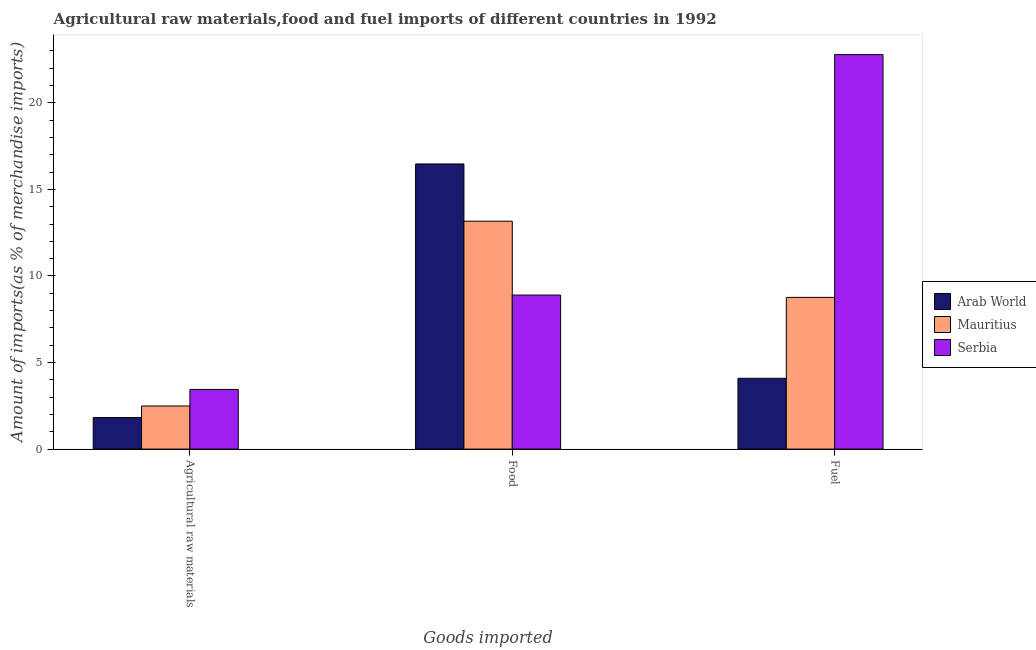How many different coloured bars are there?
Your response must be concise. 3. How many bars are there on the 1st tick from the left?
Provide a succinct answer. 3. How many bars are there on the 2nd tick from the right?
Provide a short and direct response. 3. What is the label of the 1st group of bars from the left?
Your answer should be very brief. Agricultural raw materials. What is the percentage of food imports in Serbia?
Your response must be concise. 8.9. Across all countries, what is the maximum percentage of fuel imports?
Ensure brevity in your answer.  22.79. Across all countries, what is the minimum percentage of raw materials imports?
Keep it short and to the point. 1.82. In which country was the percentage of food imports maximum?
Provide a short and direct response. Arab World. In which country was the percentage of fuel imports minimum?
Keep it short and to the point. Arab World. What is the total percentage of food imports in the graph?
Offer a very short reply. 38.53. What is the difference between the percentage of food imports in Mauritius and that in Arab World?
Provide a short and direct response. -3.31. What is the difference between the percentage of food imports in Mauritius and the percentage of raw materials imports in Serbia?
Provide a succinct answer. 9.72. What is the average percentage of raw materials imports per country?
Ensure brevity in your answer.  2.58. What is the difference between the percentage of raw materials imports and percentage of fuel imports in Arab World?
Your answer should be compact. -2.27. In how many countries, is the percentage of raw materials imports greater than 18 %?
Make the answer very short. 0. What is the ratio of the percentage of fuel imports in Mauritius to that in Arab World?
Your response must be concise. 2.14. Is the percentage of raw materials imports in Serbia less than that in Arab World?
Offer a terse response. No. Is the difference between the percentage of fuel imports in Mauritius and Arab World greater than the difference between the percentage of food imports in Mauritius and Arab World?
Offer a very short reply. Yes. What is the difference between the highest and the second highest percentage of fuel imports?
Provide a short and direct response. 14.02. What is the difference between the highest and the lowest percentage of raw materials imports?
Make the answer very short. 1.62. What does the 3rd bar from the left in Fuel represents?
Give a very brief answer. Serbia. What does the 1st bar from the right in Agricultural raw materials represents?
Keep it short and to the point. Serbia. What is the difference between two consecutive major ticks on the Y-axis?
Your answer should be compact. 5. Where does the legend appear in the graph?
Make the answer very short. Center right. How are the legend labels stacked?
Ensure brevity in your answer.  Vertical. What is the title of the graph?
Offer a very short reply. Agricultural raw materials,food and fuel imports of different countries in 1992. Does "Israel" appear as one of the legend labels in the graph?
Your response must be concise. No. What is the label or title of the X-axis?
Make the answer very short. Goods imported. What is the label or title of the Y-axis?
Ensure brevity in your answer.  Amount of imports(as % of merchandise imports). What is the Amount of imports(as % of merchandise imports) of Arab World in Agricultural raw materials?
Your answer should be compact. 1.82. What is the Amount of imports(as % of merchandise imports) in Mauritius in Agricultural raw materials?
Your response must be concise. 2.49. What is the Amount of imports(as % of merchandise imports) in Serbia in Agricultural raw materials?
Make the answer very short. 3.44. What is the Amount of imports(as % of merchandise imports) of Arab World in Food?
Your answer should be compact. 16.47. What is the Amount of imports(as % of merchandise imports) in Mauritius in Food?
Offer a terse response. 13.16. What is the Amount of imports(as % of merchandise imports) in Serbia in Food?
Provide a short and direct response. 8.9. What is the Amount of imports(as % of merchandise imports) in Arab World in Fuel?
Give a very brief answer. 4.09. What is the Amount of imports(as % of merchandise imports) of Mauritius in Fuel?
Keep it short and to the point. 8.76. What is the Amount of imports(as % of merchandise imports) in Serbia in Fuel?
Make the answer very short. 22.79. Across all Goods imported, what is the maximum Amount of imports(as % of merchandise imports) of Arab World?
Offer a very short reply. 16.47. Across all Goods imported, what is the maximum Amount of imports(as % of merchandise imports) in Mauritius?
Provide a short and direct response. 13.16. Across all Goods imported, what is the maximum Amount of imports(as % of merchandise imports) in Serbia?
Your answer should be very brief. 22.79. Across all Goods imported, what is the minimum Amount of imports(as % of merchandise imports) in Arab World?
Provide a succinct answer. 1.82. Across all Goods imported, what is the minimum Amount of imports(as % of merchandise imports) of Mauritius?
Make the answer very short. 2.49. Across all Goods imported, what is the minimum Amount of imports(as % of merchandise imports) in Serbia?
Your response must be concise. 3.44. What is the total Amount of imports(as % of merchandise imports) of Arab World in the graph?
Your answer should be very brief. 22.38. What is the total Amount of imports(as % of merchandise imports) of Mauritius in the graph?
Offer a terse response. 24.41. What is the total Amount of imports(as % of merchandise imports) of Serbia in the graph?
Offer a very short reply. 35.13. What is the difference between the Amount of imports(as % of merchandise imports) in Arab World in Agricultural raw materials and that in Food?
Offer a very short reply. -14.65. What is the difference between the Amount of imports(as % of merchandise imports) in Mauritius in Agricultural raw materials and that in Food?
Provide a succinct answer. -10.68. What is the difference between the Amount of imports(as % of merchandise imports) in Serbia in Agricultural raw materials and that in Food?
Your answer should be very brief. -5.45. What is the difference between the Amount of imports(as % of merchandise imports) of Arab World in Agricultural raw materials and that in Fuel?
Ensure brevity in your answer.  -2.27. What is the difference between the Amount of imports(as % of merchandise imports) in Mauritius in Agricultural raw materials and that in Fuel?
Your answer should be very brief. -6.27. What is the difference between the Amount of imports(as % of merchandise imports) of Serbia in Agricultural raw materials and that in Fuel?
Offer a very short reply. -19.34. What is the difference between the Amount of imports(as % of merchandise imports) of Arab World in Food and that in Fuel?
Make the answer very short. 12.38. What is the difference between the Amount of imports(as % of merchandise imports) of Mauritius in Food and that in Fuel?
Provide a short and direct response. 4.4. What is the difference between the Amount of imports(as % of merchandise imports) in Serbia in Food and that in Fuel?
Keep it short and to the point. -13.89. What is the difference between the Amount of imports(as % of merchandise imports) in Arab World in Agricultural raw materials and the Amount of imports(as % of merchandise imports) in Mauritius in Food?
Keep it short and to the point. -11.34. What is the difference between the Amount of imports(as % of merchandise imports) in Arab World in Agricultural raw materials and the Amount of imports(as % of merchandise imports) in Serbia in Food?
Offer a terse response. -7.08. What is the difference between the Amount of imports(as % of merchandise imports) in Mauritius in Agricultural raw materials and the Amount of imports(as % of merchandise imports) in Serbia in Food?
Make the answer very short. -6.41. What is the difference between the Amount of imports(as % of merchandise imports) of Arab World in Agricultural raw materials and the Amount of imports(as % of merchandise imports) of Mauritius in Fuel?
Offer a very short reply. -6.94. What is the difference between the Amount of imports(as % of merchandise imports) of Arab World in Agricultural raw materials and the Amount of imports(as % of merchandise imports) of Serbia in Fuel?
Your response must be concise. -20.97. What is the difference between the Amount of imports(as % of merchandise imports) in Mauritius in Agricultural raw materials and the Amount of imports(as % of merchandise imports) in Serbia in Fuel?
Provide a succinct answer. -20.3. What is the difference between the Amount of imports(as % of merchandise imports) in Arab World in Food and the Amount of imports(as % of merchandise imports) in Mauritius in Fuel?
Provide a short and direct response. 7.71. What is the difference between the Amount of imports(as % of merchandise imports) in Arab World in Food and the Amount of imports(as % of merchandise imports) in Serbia in Fuel?
Your answer should be compact. -6.32. What is the difference between the Amount of imports(as % of merchandise imports) in Mauritius in Food and the Amount of imports(as % of merchandise imports) in Serbia in Fuel?
Give a very brief answer. -9.62. What is the average Amount of imports(as % of merchandise imports) of Arab World per Goods imported?
Your response must be concise. 7.46. What is the average Amount of imports(as % of merchandise imports) of Mauritius per Goods imported?
Offer a very short reply. 8.14. What is the average Amount of imports(as % of merchandise imports) in Serbia per Goods imported?
Your answer should be compact. 11.71. What is the difference between the Amount of imports(as % of merchandise imports) in Arab World and Amount of imports(as % of merchandise imports) in Mauritius in Agricultural raw materials?
Give a very brief answer. -0.67. What is the difference between the Amount of imports(as % of merchandise imports) in Arab World and Amount of imports(as % of merchandise imports) in Serbia in Agricultural raw materials?
Your response must be concise. -1.62. What is the difference between the Amount of imports(as % of merchandise imports) in Mauritius and Amount of imports(as % of merchandise imports) in Serbia in Agricultural raw materials?
Make the answer very short. -0.96. What is the difference between the Amount of imports(as % of merchandise imports) of Arab World and Amount of imports(as % of merchandise imports) of Mauritius in Food?
Provide a short and direct response. 3.31. What is the difference between the Amount of imports(as % of merchandise imports) of Arab World and Amount of imports(as % of merchandise imports) of Serbia in Food?
Make the answer very short. 7.57. What is the difference between the Amount of imports(as % of merchandise imports) of Mauritius and Amount of imports(as % of merchandise imports) of Serbia in Food?
Provide a succinct answer. 4.27. What is the difference between the Amount of imports(as % of merchandise imports) in Arab World and Amount of imports(as % of merchandise imports) in Mauritius in Fuel?
Your response must be concise. -4.67. What is the difference between the Amount of imports(as % of merchandise imports) in Arab World and Amount of imports(as % of merchandise imports) in Serbia in Fuel?
Your answer should be compact. -18.7. What is the difference between the Amount of imports(as % of merchandise imports) of Mauritius and Amount of imports(as % of merchandise imports) of Serbia in Fuel?
Provide a short and direct response. -14.02. What is the ratio of the Amount of imports(as % of merchandise imports) in Arab World in Agricultural raw materials to that in Food?
Offer a terse response. 0.11. What is the ratio of the Amount of imports(as % of merchandise imports) in Mauritius in Agricultural raw materials to that in Food?
Your answer should be very brief. 0.19. What is the ratio of the Amount of imports(as % of merchandise imports) in Serbia in Agricultural raw materials to that in Food?
Provide a succinct answer. 0.39. What is the ratio of the Amount of imports(as % of merchandise imports) of Arab World in Agricultural raw materials to that in Fuel?
Your response must be concise. 0.45. What is the ratio of the Amount of imports(as % of merchandise imports) in Mauritius in Agricultural raw materials to that in Fuel?
Offer a terse response. 0.28. What is the ratio of the Amount of imports(as % of merchandise imports) of Serbia in Agricultural raw materials to that in Fuel?
Make the answer very short. 0.15. What is the ratio of the Amount of imports(as % of merchandise imports) of Arab World in Food to that in Fuel?
Your response must be concise. 4.03. What is the ratio of the Amount of imports(as % of merchandise imports) of Mauritius in Food to that in Fuel?
Make the answer very short. 1.5. What is the ratio of the Amount of imports(as % of merchandise imports) in Serbia in Food to that in Fuel?
Keep it short and to the point. 0.39. What is the difference between the highest and the second highest Amount of imports(as % of merchandise imports) of Arab World?
Ensure brevity in your answer.  12.38. What is the difference between the highest and the second highest Amount of imports(as % of merchandise imports) of Mauritius?
Make the answer very short. 4.4. What is the difference between the highest and the second highest Amount of imports(as % of merchandise imports) of Serbia?
Offer a terse response. 13.89. What is the difference between the highest and the lowest Amount of imports(as % of merchandise imports) in Arab World?
Offer a very short reply. 14.65. What is the difference between the highest and the lowest Amount of imports(as % of merchandise imports) of Mauritius?
Your response must be concise. 10.68. What is the difference between the highest and the lowest Amount of imports(as % of merchandise imports) in Serbia?
Keep it short and to the point. 19.34. 